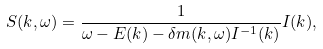Convert formula to latex. <formula><loc_0><loc_0><loc_500><loc_500>S ( { k } , \omega ) = \frac { 1 } { \omega - { E } ( { k } ) - \delta { m } ( { k } , \omega ) { I } ^ { - 1 } ( { k } ) } { I } ( { k } ) ,</formula> 